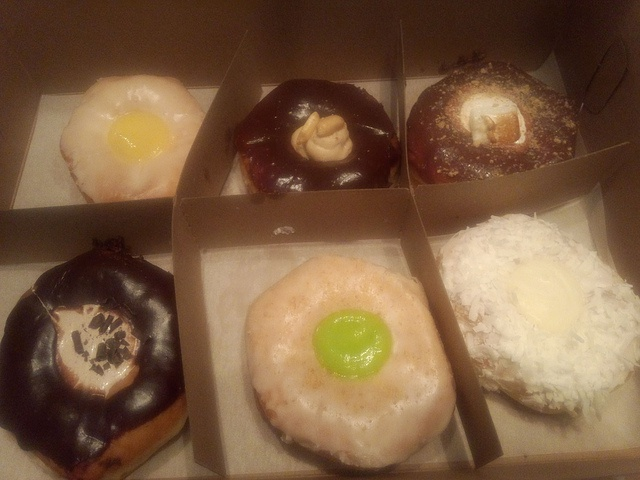Describe the objects in this image and their specific colors. I can see donut in maroon, tan, and gray tones, donut in maroon, black, and tan tones, donut in maroon, tan, and gray tones, donut in maroon and tan tones, and donut in maroon, brown, and gray tones in this image. 